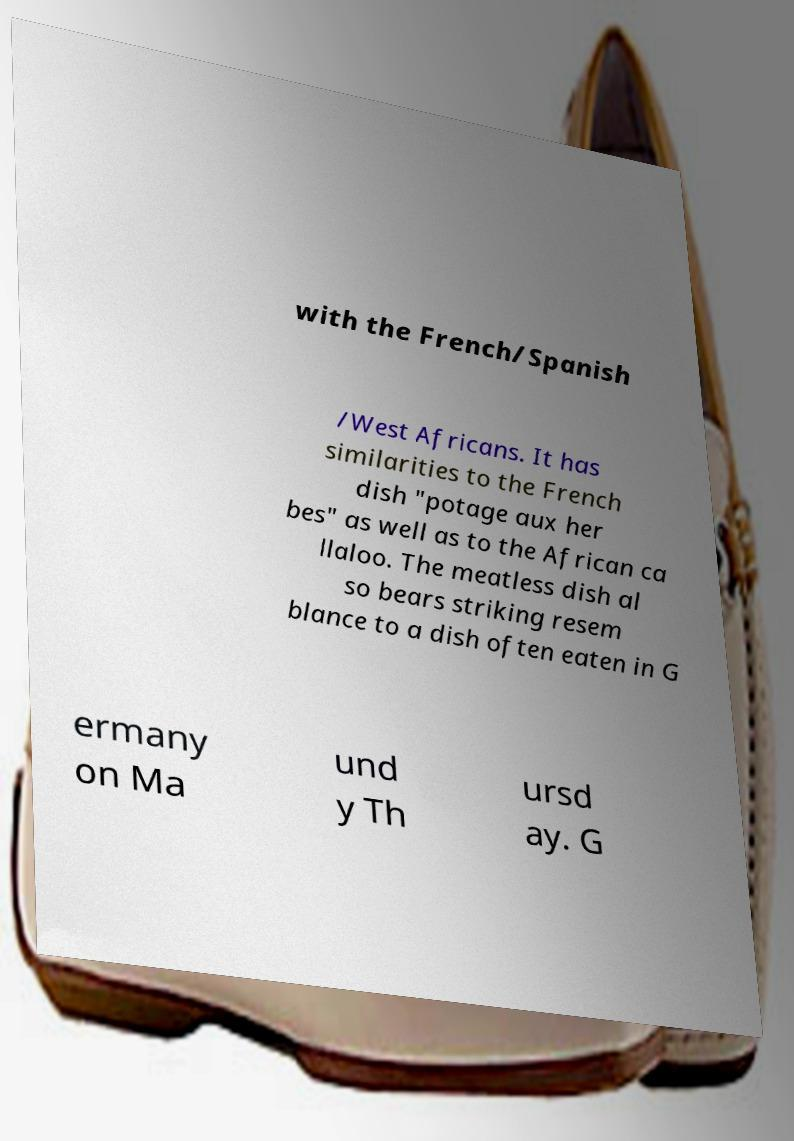Please identify and transcribe the text found in this image. with the French/Spanish /West Africans. It has similarities to the French dish "potage aux her bes" as well as to the African ca llaloo. The meatless dish al so bears striking resem blance to a dish often eaten in G ermany on Ma und y Th ursd ay. G 